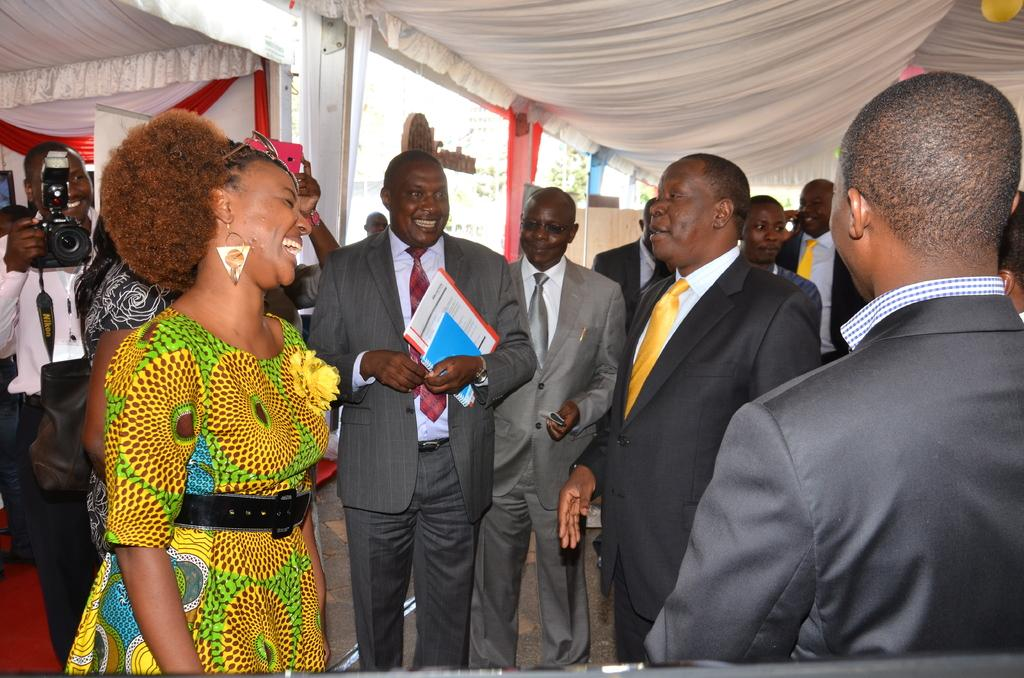What is happening under the tent in the image? There are many people standing under the tent in the image. How are the people feeling in the image? The people are smiling in the image. What is the man on the right side holding in his hand? The man on the right side is holding books in his hand. What is the man on the left side doing in the image? The man on the left side is holding a camera in his hand. What type of behavior is the dog exhibiting in the image? There is no dog present in the image; it only features people standing under a tent, smiling, and holding books and a camera. 